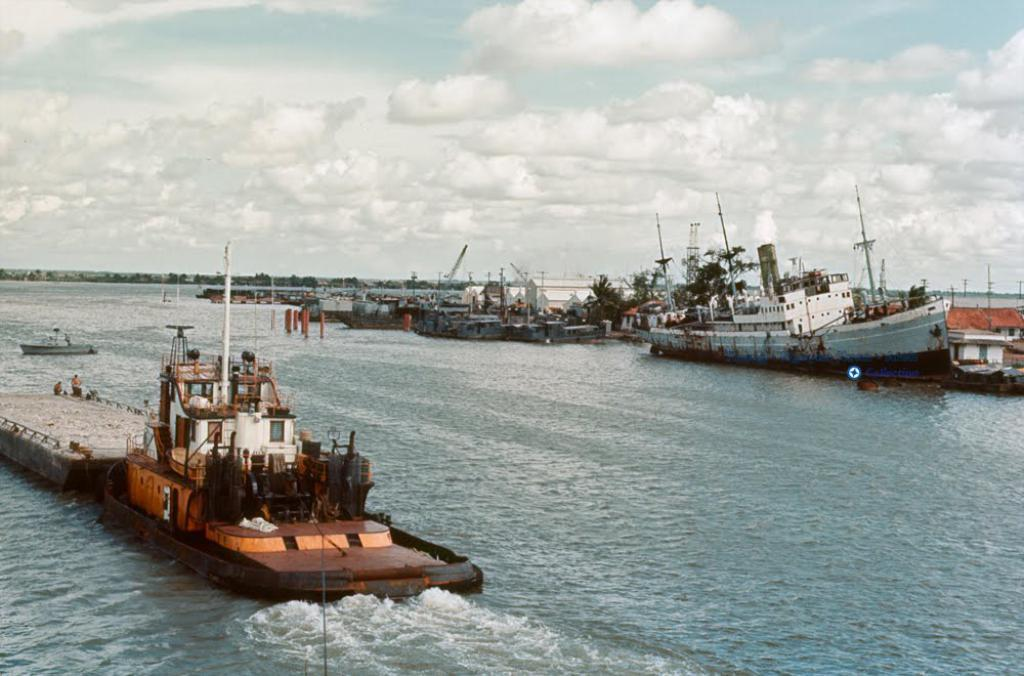What is the main subject in the foreground of the picture? There is a water body in the foreground of the picture. What types of watercraft are present in the water? Ships and boats are present in the water. What can be seen in the image besides the water and watercraft? Trees, people, and various objects are present in the water. What is visible at the top of the image? The sky is visible at the top of the image. What is the condition of the sky in the image? The sky is cloudy in the image. What type of creature is swimming alongside the ships in the image? There is no creature swimming alongside the ships in the image; only ships, boats, and various objects are present in the water. Can you identify any actors in the image? There are no actors present in the image; it features a water body, ships, boats, trees, people, and various objects in the water. 